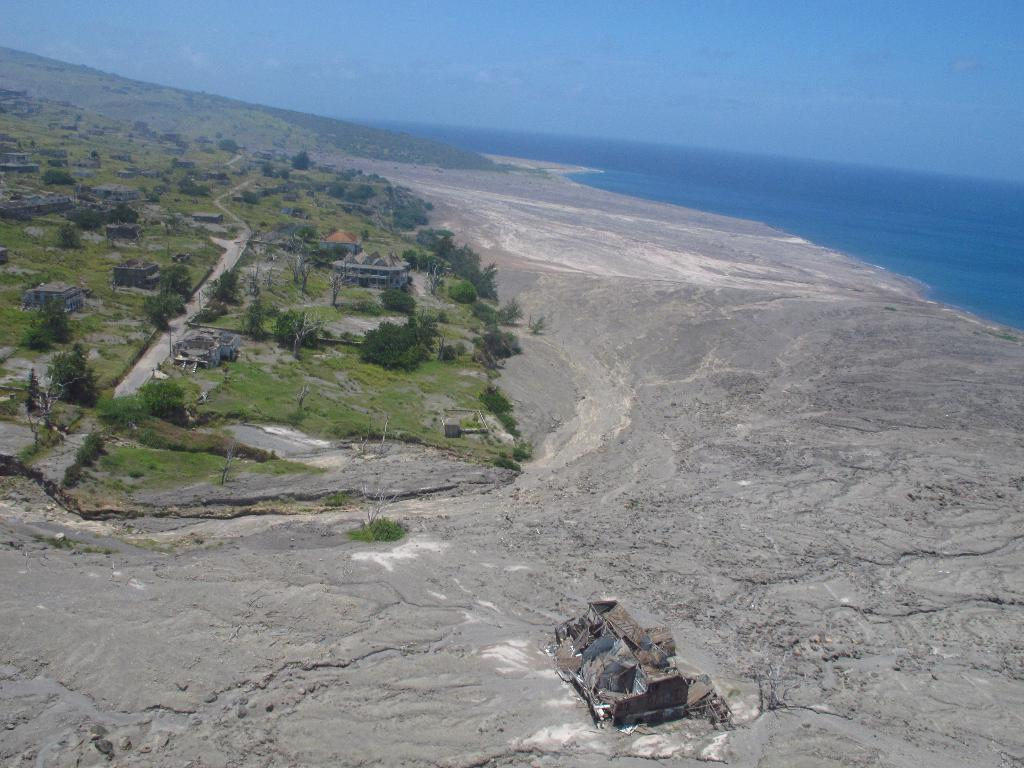What type of structures are present in the image? There are houses in the image. What type of vegetation can be seen in the image? There are trees and grass in the image. What is the ground like in the image? The ground is visible in the image. What else can be seen in the image besides the houses and vegetation? There is water visible in the image. What is visible at the top of the image? The sky is visible at the top of the image. What type of hospital can be seen in the image? There is no hospital present in the image. What impulse might the grass have in the image? The grass does not have any impulses, as it is an inanimate object. 